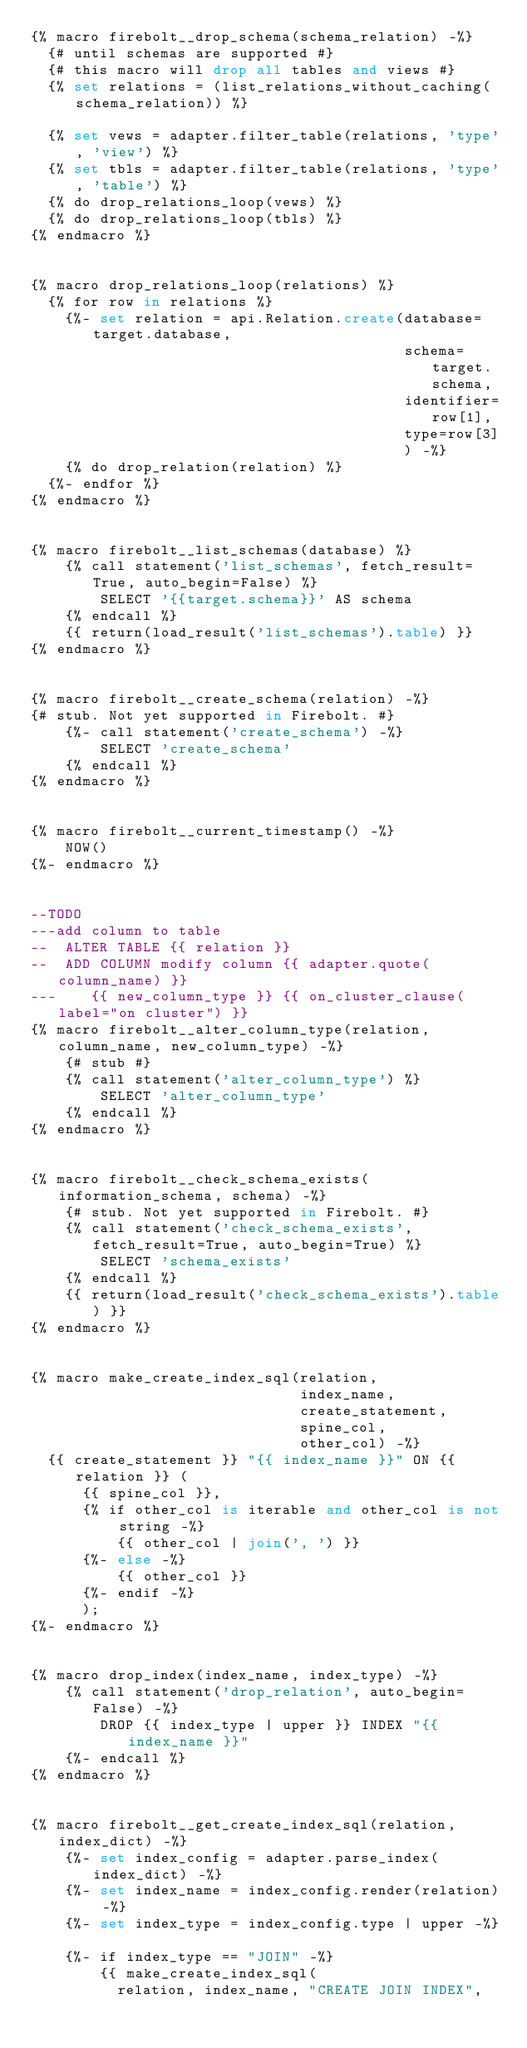Convert code to text. <code><loc_0><loc_0><loc_500><loc_500><_SQL_>{% macro firebolt__drop_schema(schema_relation) -%}
  {# until schemas are supported #}
  {# this macro will drop all tables and views #}
  {% set relations = (list_relations_without_caching(schema_relation)) %}

  {% set vews = adapter.filter_table(relations, 'type', 'view') %}
  {% set tbls = adapter.filter_table(relations, 'type', 'table') %}
  {% do drop_relations_loop(vews) %}
  {% do drop_relations_loop(tbls) %}
{% endmacro %}


{% macro drop_relations_loop(relations) %}
  {% for row in relations %}
    {%- set relation = api.Relation.create(database=target.database,
                                           schema=target.schema,
                                           identifier=row[1],
                                           type=row[3]
                                           ) -%}
    {% do drop_relation(relation) %}
  {%- endfor %}
{% endmacro %}


{% macro firebolt__list_schemas(database) %}
    {% call statement('list_schemas', fetch_result=True, auto_begin=False) %}
        SELECT '{{target.schema}}' AS schema
    {% endcall %}
    {{ return(load_result('list_schemas').table) }}
{% endmacro %}


{% macro firebolt__create_schema(relation) -%}
{# stub. Not yet supported in Firebolt. #}
    {%- call statement('create_schema') -%}
        SELECT 'create_schema'
    {% endcall %}
{% endmacro %}


{% macro firebolt__current_timestamp() -%}
    NOW()
{%- endmacro %}


--TODO
---add column to table
--  ALTER TABLE {{ relation }}
--  ADD COLUMN modify column {{ adapter.quote(column_name) }}
---    {{ new_column_type }} {{ on_cluster_clause(label="on cluster") }}
{% macro firebolt__alter_column_type(relation, column_name, new_column_type) -%}
    {# stub #}
    {% call statement('alter_column_type') %}
        SELECT 'alter_column_type'
    {% endcall %}
{% endmacro %}


{% macro firebolt__check_schema_exists(information_schema, schema) -%}
    {# stub. Not yet supported in Firebolt. #}
    {% call statement('check_schema_exists', fetch_result=True, auto_begin=True) %}
        SELECT 'schema_exists'
    {% endcall %}
    {{ return(load_result('check_schema_exists').table) }}
{% endmacro %}


{% macro make_create_index_sql(relation,
                               index_name,
                               create_statement,
                               spine_col,
                               other_col) -%}
  {{ create_statement }} "{{ index_name }}" ON {{ relation }} (
      {{ spine_col }},
      {% if other_col is iterable and other_col is not string -%}
          {{ other_col | join(', ') }}
      {%- else -%}
          {{ other_col }}
      {%- endif -%}
      );
{%- endmacro %}


{% macro drop_index(index_name, index_type) -%}
    {% call statement('drop_relation', auto_begin=False) -%}
        DROP {{ index_type | upper }} INDEX "{{ index_name }}"
    {%- endcall %}
{% endmacro %}


{% macro firebolt__get_create_index_sql(relation, index_dict) -%}
    {%- set index_config = adapter.parse_index(index_dict) -%}
    {%- set index_name = index_config.render(relation) -%}
    {%- set index_type = index_config.type | upper -%}

    {%- if index_type == "JOIN" -%}
        {{ make_create_index_sql(
          relation, index_name, "CREATE JOIN INDEX",</code> 